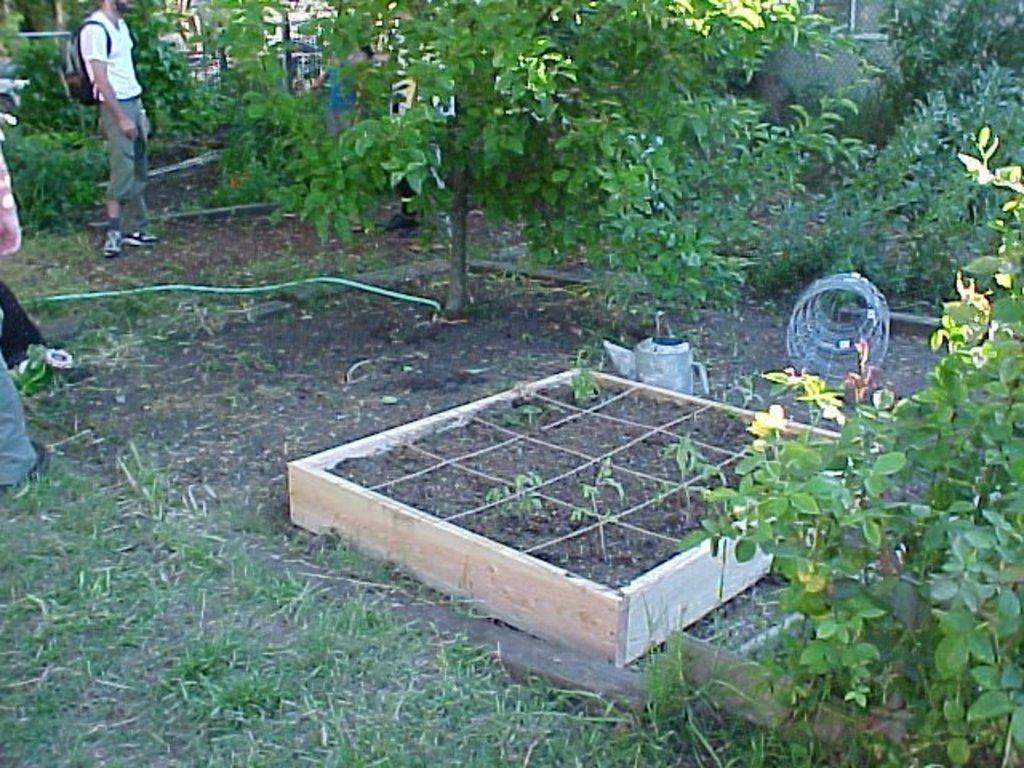How would you summarize this image in a sentence or two? In this image there is a person standing and wearing a bag, there is a person truncated towards the left of the image, there is the grass, there are plants, there are trees, there are trees truncated towards the top of the image, there are trees truncated towards the right of the image, there are objects on the ground, there are windows truncated towards the top of the image, there is the wall. 